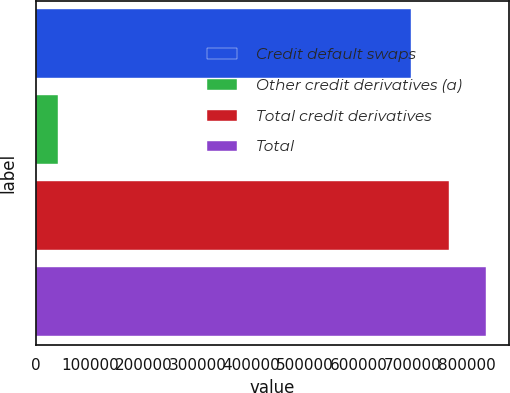<chart> <loc_0><loc_0><loc_500><loc_500><bar_chart><fcel>Credit default swaps<fcel>Other credit derivatives (a)<fcel>Total credit derivatives<fcel>Total<nl><fcel>697220<fcel>41244<fcel>766942<fcel>836664<nl></chart> 